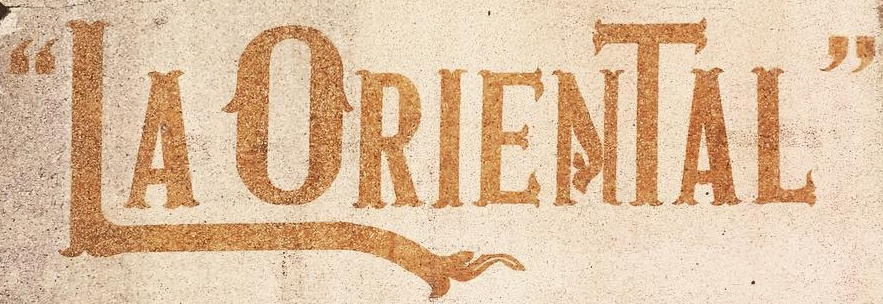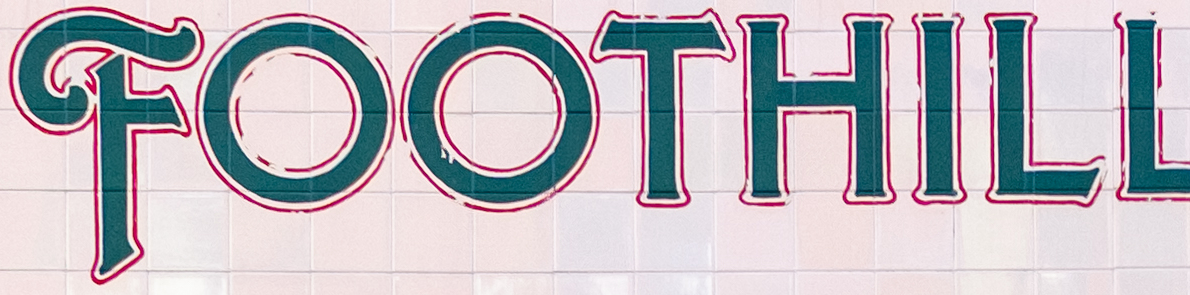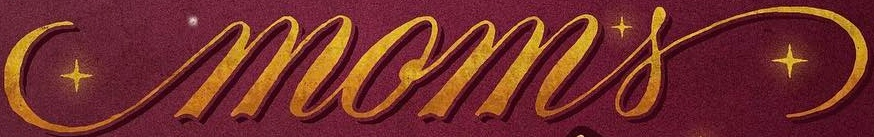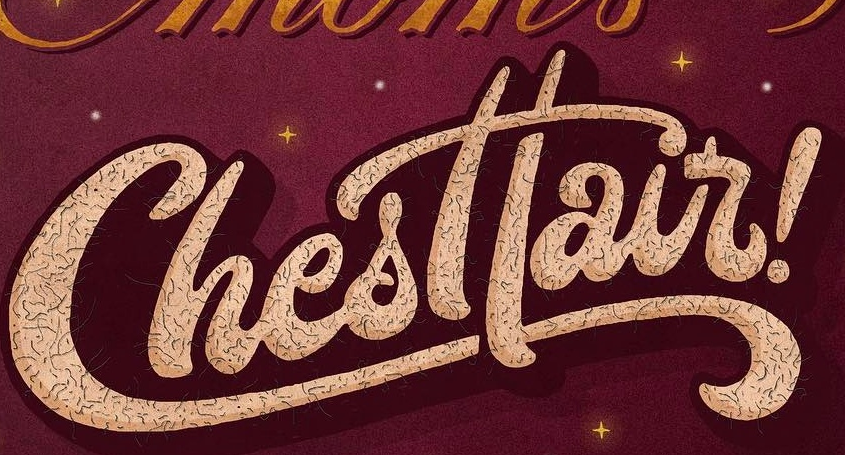What words are shown in these images in order, separated by a semicolon? “LAORIENTAL"; FOOTHILL; moms; Chesttair 